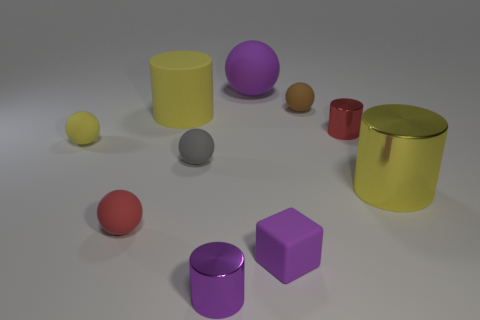How many other objects are there of the same color as the big rubber cylinder?
Keep it short and to the point. 2. What number of purple things are tiny cylinders or rubber cylinders?
Ensure brevity in your answer.  1. Is there a metallic cylinder behind the purple object behind the tiny cylinder that is on the right side of the brown object?
Your answer should be compact. No. Is the large shiny cylinder the same color as the cube?
Keep it short and to the point. No. What color is the large object that is to the right of the tiny red object on the right side of the purple rubber ball?
Your answer should be compact. Yellow. How many tiny things are either yellow rubber balls or yellow rubber objects?
Provide a short and direct response. 1. What color is the tiny rubber thing that is on the left side of the brown thing and right of the purple metal cylinder?
Give a very brief answer. Purple. Is the material of the small gray sphere the same as the red cylinder?
Ensure brevity in your answer.  No. What shape is the purple shiny object?
Your answer should be compact. Cylinder. What number of yellow metallic things are on the left side of the red thing that is behind the big cylinder on the right side of the purple cylinder?
Keep it short and to the point. 0. 